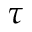<formula> <loc_0><loc_0><loc_500><loc_500>\tau</formula> 